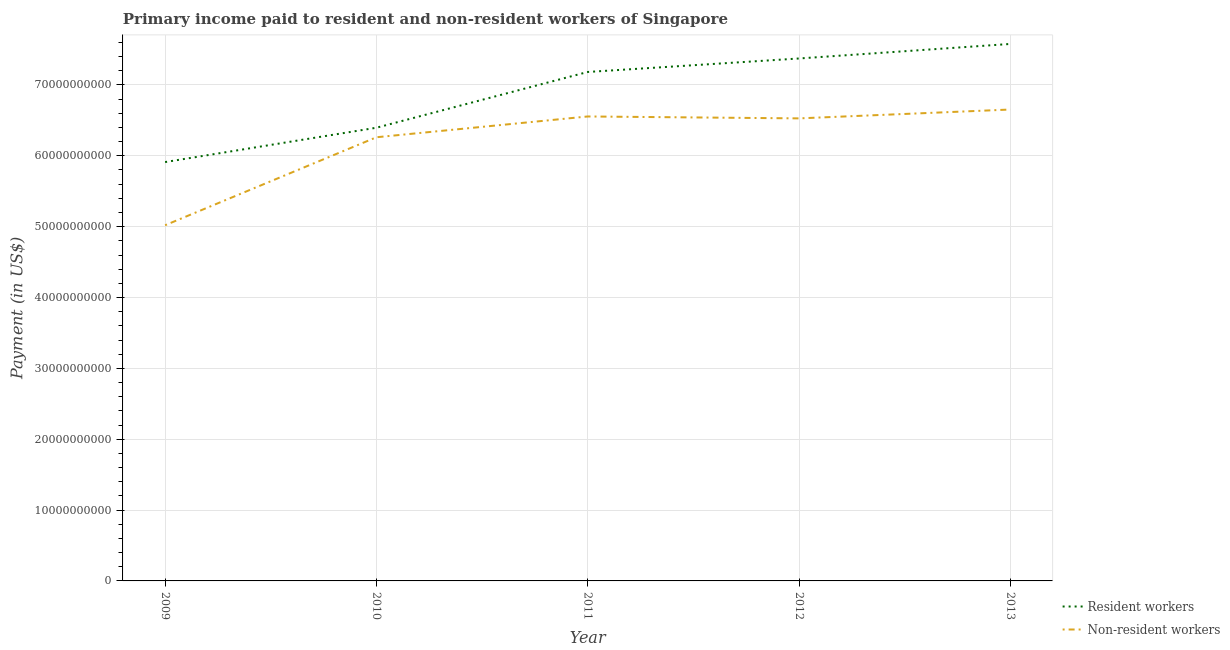Is the number of lines equal to the number of legend labels?
Keep it short and to the point. Yes. What is the payment made to resident workers in 2009?
Make the answer very short. 5.91e+1. Across all years, what is the maximum payment made to resident workers?
Your response must be concise. 7.58e+1. Across all years, what is the minimum payment made to non-resident workers?
Your response must be concise. 5.02e+1. In which year was the payment made to resident workers maximum?
Make the answer very short. 2013. What is the total payment made to non-resident workers in the graph?
Your response must be concise. 3.10e+11. What is the difference between the payment made to non-resident workers in 2010 and that in 2012?
Offer a terse response. -2.66e+09. What is the difference between the payment made to non-resident workers in 2012 and the payment made to resident workers in 2010?
Provide a succinct answer. 1.32e+09. What is the average payment made to non-resident workers per year?
Provide a succinct answer. 6.20e+1. In the year 2009, what is the difference between the payment made to non-resident workers and payment made to resident workers?
Provide a succinct answer. -8.92e+09. In how many years, is the payment made to non-resident workers greater than 20000000000 US$?
Make the answer very short. 5. What is the ratio of the payment made to non-resident workers in 2010 to that in 2012?
Offer a very short reply. 0.96. Is the payment made to resident workers in 2010 less than that in 2012?
Provide a short and direct response. Yes. What is the difference between the highest and the second highest payment made to non-resident workers?
Offer a very short reply. 9.81e+08. What is the difference between the highest and the lowest payment made to resident workers?
Give a very brief answer. 1.67e+1. In how many years, is the payment made to resident workers greater than the average payment made to resident workers taken over all years?
Offer a very short reply. 3. Is the sum of the payment made to non-resident workers in 2009 and 2011 greater than the maximum payment made to resident workers across all years?
Give a very brief answer. Yes. Does the payment made to non-resident workers monotonically increase over the years?
Your answer should be compact. No. Is the payment made to resident workers strictly less than the payment made to non-resident workers over the years?
Your answer should be very brief. No. How many lines are there?
Make the answer very short. 2. What is the difference between two consecutive major ticks on the Y-axis?
Offer a very short reply. 1.00e+1. Does the graph contain grids?
Your response must be concise. Yes. How many legend labels are there?
Give a very brief answer. 2. What is the title of the graph?
Your answer should be compact. Primary income paid to resident and non-resident workers of Singapore. Does "Automatic Teller Machines" appear as one of the legend labels in the graph?
Your answer should be compact. No. What is the label or title of the Y-axis?
Offer a very short reply. Payment (in US$). What is the Payment (in US$) in Resident workers in 2009?
Give a very brief answer. 5.91e+1. What is the Payment (in US$) of Non-resident workers in 2009?
Keep it short and to the point. 5.02e+1. What is the Payment (in US$) in Resident workers in 2010?
Your answer should be compact. 6.40e+1. What is the Payment (in US$) of Non-resident workers in 2010?
Ensure brevity in your answer.  6.26e+1. What is the Payment (in US$) of Resident workers in 2011?
Give a very brief answer. 7.18e+1. What is the Payment (in US$) of Non-resident workers in 2011?
Provide a short and direct response. 6.56e+1. What is the Payment (in US$) in Resident workers in 2012?
Offer a very short reply. 7.37e+1. What is the Payment (in US$) in Non-resident workers in 2012?
Provide a short and direct response. 6.53e+1. What is the Payment (in US$) in Resident workers in 2013?
Ensure brevity in your answer.  7.58e+1. What is the Payment (in US$) in Non-resident workers in 2013?
Keep it short and to the point. 6.65e+1. Across all years, what is the maximum Payment (in US$) of Resident workers?
Your answer should be compact. 7.58e+1. Across all years, what is the maximum Payment (in US$) of Non-resident workers?
Provide a succinct answer. 6.65e+1. Across all years, what is the minimum Payment (in US$) in Resident workers?
Provide a succinct answer. 5.91e+1. Across all years, what is the minimum Payment (in US$) in Non-resident workers?
Give a very brief answer. 5.02e+1. What is the total Payment (in US$) of Resident workers in the graph?
Provide a short and direct response. 3.44e+11. What is the total Payment (in US$) in Non-resident workers in the graph?
Offer a terse response. 3.10e+11. What is the difference between the Payment (in US$) in Resident workers in 2009 and that in 2010?
Offer a terse response. -4.85e+09. What is the difference between the Payment (in US$) of Non-resident workers in 2009 and that in 2010?
Ensure brevity in your answer.  -1.24e+1. What is the difference between the Payment (in US$) in Resident workers in 2009 and that in 2011?
Provide a succinct answer. -1.27e+1. What is the difference between the Payment (in US$) of Non-resident workers in 2009 and that in 2011?
Give a very brief answer. -1.54e+1. What is the difference between the Payment (in US$) in Resident workers in 2009 and that in 2012?
Make the answer very short. -1.46e+1. What is the difference between the Payment (in US$) in Non-resident workers in 2009 and that in 2012?
Keep it short and to the point. -1.51e+1. What is the difference between the Payment (in US$) in Resident workers in 2009 and that in 2013?
Your answer should be compact. -1.67e+1. What is the difference between the Payment (in US$) of Non-resident workers in 2009 and that in 2013?
Your answer should be very brief. -1.63e+1. What is the difference between the Payment (in US$) in Resident workers in 2010 and that in 2011?
Offer a terse response. -7.87e+09. What is the difference between the Payment (in US$) of Non-resident workers in 2010 and that in 2011?
Provide a short and direct response. -2.93e+09. What is the difference between the Payment (in US$) in Resident workers in 2010 and that in 2012?
Keep it short and to the point. -9.77e+09. What is the difference between the Payment (in US$) of Non-resident workers in 2010 and that in 2012?
Provide a short and direct response. -2.66e+09. What is the difference between the Payment (in US$) of Resident workers in 2010 and that in 2013?
Your response must be concise. -1.18e+1. What is the difference between the Payment (in US$) in Non-resident workers in 2010 and that in 2013?
Offer a terse response. -3.91e+09. What is the difference between the Payment (in US$) of Resident workers in 2011 and that in 2012?
Offer a very short reply. -1.90e+09. What is the difference between the Payment (in US$) in Non-resident workers in 2011 and that in 2012?
Provide a short and direct response. 2.70e+08. What is the difference between the Payment (in US$) of Resident workers in 2011 and that in 2013?
Make the answer very short. -3.96e+09. What is the difference between the Payment (in US$) of Non-resident workers in 2011 and that in 2013?
Ensure brevity in your answer.  -9.81e+08. What is the difference between the Payment (in US$) in Resident workers in 2012 and that in 2013?
Offer a terse response. -2.05e+09. What is the difference between the Payment (in US$) of Non-resident workers in 2012 and that in 2013?
Offer a very short reply. -1.25e+09. What is the difference between the Payment (in US$) of Resident workers in 2009 and the Payment (in US$) of Non-resident workers in 2010?
Your answer should be very brief. -3.50e+09. What is the difference between the Payment (in US$) in Resident workers in 2009 and the Payment (in US$) in Non-resident workers in 2011?
Provide a short and direct response. -6.44e+09. What is the difference between the Payment (in US$) of Resident workers in 2009 and the Payment (in US$) of Non-resident workers in 2012?
Your answer should be very brief. -6.17e+09. What is the difference between the Payment (in US$) of Resident workers in 2009 and the Payment (in US$) of Non-resident workers in 2013?
Give a very brief answer. -7.42e+09. What is the difference between the Payment (in US$) in Resident workers in 2010 and the Payment (in US$) in Non-resident workers in 2011?
Offer a terse response. -1.59e+09. What is the difference between the Payment (in US$) of Resident workers in 2010 and the Payment (in US$) of Non-resident workers in 2012?
Give a very brief answer. -1.32e+09. What is the difference between the Payment (in US$) in Resident workers in 2010 and the Payment (in US$) in Non-resident workers in 2013?
Provide a succinct answer. -2.57e+09. What is the difference between the Payment (in US$) of Resident workers in 2011 and the Payment (in US$) of Non-resident workers in 2012?
Offer a terse response. 6.55e+09. What is the difference between the Payment (in US$) of Resident workers in 2011 and the Payment (in US$) of Non-resident workers in 2013?
Your response must be concise. 5.30e+09. What is the difference between the Payment (in US$) of Resident workers in 2012 and the Payment (in US$) of Non-resident workers in 2013?
Your answer should be compact. 7.20e+09. What is the average Payment (in US$) of Resident workers per year?
Make the answer very short. 6.89e+1. What is the average Payment (in US$) in Non-resident workers per year?
Your answer should be very brief. 6.20e+1. In the year 2009, what is the difference between the Payment (in US$) in Resident workers and Payment (in US$) in Non-resident workers?
Offer a terse response. 8.92e+09. In the year 2010, what is the difference between the Payment (in US$) of Resident workers and Payment (in US$) of Non-resident workers?
Give a very brief answer. 1.35e+09. In the year 2011, what is the difference between the Payment (in US$) of Resident workers and Payment (in US$) of Non-resident workers?
Give a very brief answer. 6.28e+09. In the year 2012, what is the difference between the Payment (in US$) in Resident workers and Payment (in US$) in Non-resident workers?
Your response must be concise. 8.46e+09. In the year 2013, what is the difference between the Payment (in US$) of Resident workers and Payment (in US$) of Non-resident workers?
Offer a terse response. 9.26e+09. What is the ratio of the Payment (in US$) in Resident workers in 2009 to that in 2010?
Your answer should be very brief. 0.92. What is the ratio of the Payment (in US$) in Non-resident workers in 2009 to that in 2010?
Provide a succinct answer. 0.8. What is the ratio of the Payment (in US$) of Resident workers in 2009 to that in 2011?
Provide a short and direct response. 0.82. What is the ratio of the Payment (in US$) in Non-resident workers in 2009 to that in 2011?
Your answer should be compact. 0.77. What is the ratio of the Payment (in US$) in Resident workers in 2009 to that in 2012?
Your answer should be compact. 0.8. What is the ratio of the Payment (in US$) of Non-resident workers in 2009 to that in 2012?
Offer a terse response. 0.77. What is the ratio of the Payment (in US$) of Resident workers in 2009 to that in 2013?
Ensure brevity in your answer.  0.78. What is the ratio of the Payment (in US$) in Non-resident workers in 2009 to that in 2013?
Offer a very short reply. 0.75. What is the ratio of the Payment (in US$) in Resident workers in 2010 to that in 2011?
Your answer should be compact. 0.89. What is the ratio of the Payment (in US$) in Non-resident workers in 2010 to that in 2011?
Your answer should be very brief. 0.96. What is the ratio of the Payment (in US$) of Resident workers in 2010 to that in 2012?
Provide a succinct answer. 0.87. What is the ratio of the Payment (in US$) in Non-resident workers in 2010 to that in 2012?
Ensure brevity in your answer.  0.96. What is the ratio of the Payment (in US$) of Resident workers in 2010 to that in 2013?
Provide a succinct answer. 0.84. What is the ratio of the Payment (in US$) in Resident workers in 2011 to that in 2012?
Your response must be concise. 0.97. What is the ratio of the Payment (in US$) in Resident workers in 2011 to that in 2013?
Make the answer very short. 0.95. What is the ratio of the Payment (in US$) in Resident workers in 2012 to that in 2013?
Provide a short and direct response. 0.97. What is the ratio of the Payment (in US$) of Non-resident workers in 2012 to that in 2013?
Ensure brevity in your answer.  0.98. What is the difference between the highest and the second highest Payment (in US$) of Resident workers?
Ensure brevity in your answer.  2.05e+09. What is the difference between the highest and the second highest Payment (in US$) of Non-resident workers?
Give a very brief answer. 9.81e+08. What is the difference between the highest and the lowest Payment (in US$) of Resident workers?
Your answer should be compact. 1.67e+1. What is the difference between the highest and the lowest Payment (in US$) in Non-resident workers?
Keep it short and to the point. 1.63e+1. 